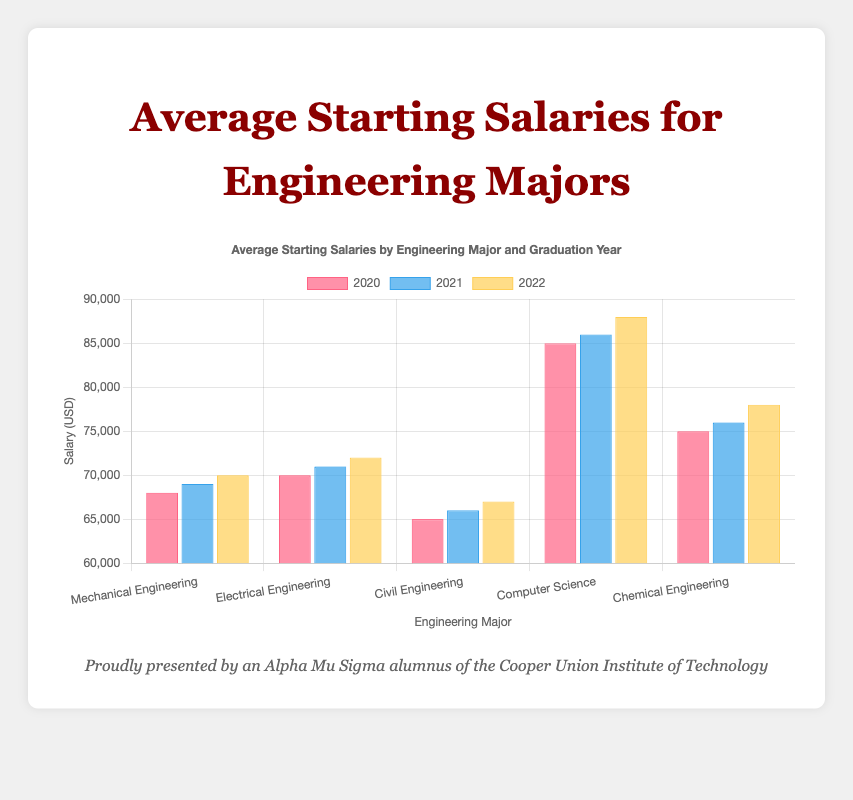What is the average starting salary for Computer Science majors across all years? To find the average, add the starting salaries for Computer Science majors across 2020, 2021, and 2022, then divide by the number of years. The salaries are 85000, 86000, and 88000. The sum is 85000 + 86000 + 88000 = 259000. Dividing by 3, the average is 259000 / 3 = 86333.33
Answer: 86333.33 Which major had the highest starting salary in 2022? Refer to the heights of the bars in 2022 for each major. In 2022, Computer Science has the highest starting salary bar with 88000
Answer: Computer Science Is the starting salary for Mechanical Engineering in 2021 higher or lower than the starting salary for Electrical Engineering in 2020? Compare the heights of the bars: Mechanical Engineering's starting salary in 2021 is 69000, and Electrical Engineering's starting salary in 2020 is 70000. 69000 < 70000, so it is lower
Answer: Lower What is the total starting salary for Civil Engineering majors for all years combined? Add the starting salaries for Civil Engineering majors for 2020, 2021, and 2022. The salaries are 65000, 66000, and 67000. Their sum is 65000 + 66000 + 67000 = 198000
Answer: 198000 How does the starting salary for Chemical Engineering in 2020 compare to that of Mechanical Engineering in 2022? Compare the heights of the bars: Chemical Engineering's starting salary in 2020 is 75000, and Mechanical Engineering's starting salary in 2022 is 70000. 75000 > 70000, so it is higher
Answer: Higher What is the increase in starting salary for Electrical Engineering majors from 2020 to 2022? Subtract the 2020 salary from the 2022 salary for Electrical Engineering. The salaries are 70000 in 2020 and 72000 in 2022. The increase is 72000 - 70000 = 2000
Answer: 2000 What is the difference between the highest and lowest starting salaries for any major in 2021? Identify the highest and lowest bars for any major in 2021. The highest is Computer Science at 86000, and the lowest is Civil Engineering at 66000. The difference is 86000 - 66000 = 20000
Answer: 20000 Is there any major whose starting salary did not change between consecutive years? Compare the starting salaries for all majors. None of the salaries remained constant between consecutive years; every major exhibited a salary increase from 2020 to 2021 and 2021 to 2022
Answer: No 